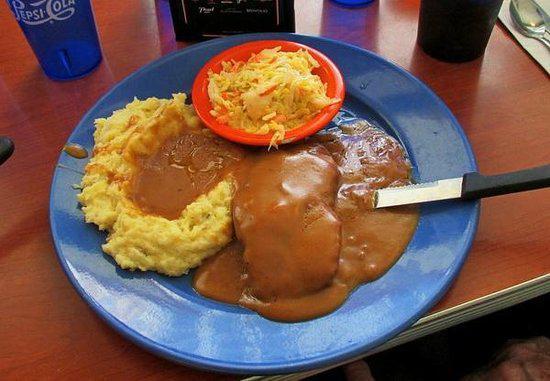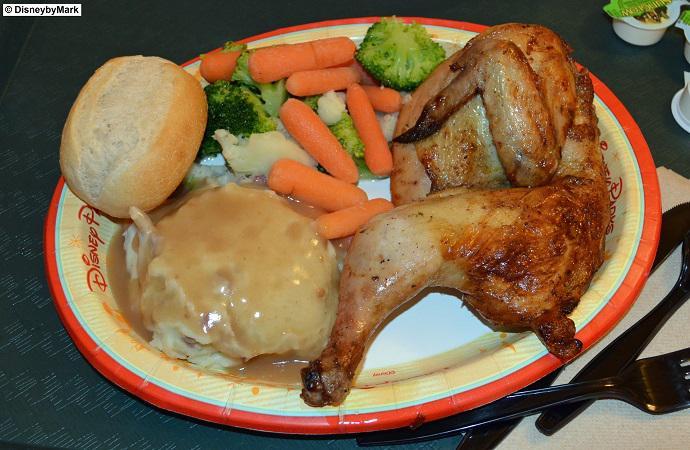The first image is the image on the left, the second image is the image on the right. Considering the images on both sides, is "A dish featuring mashed potatoes with gravy has a bright red rim." valid? Answer yes or no. Yes. The first image is the image on the left, the second image is the image on the right. Assess this claim about the two images: "In one image there is one or more utensils on the plate.". Correct or not? Answer yes or no. Yes. 